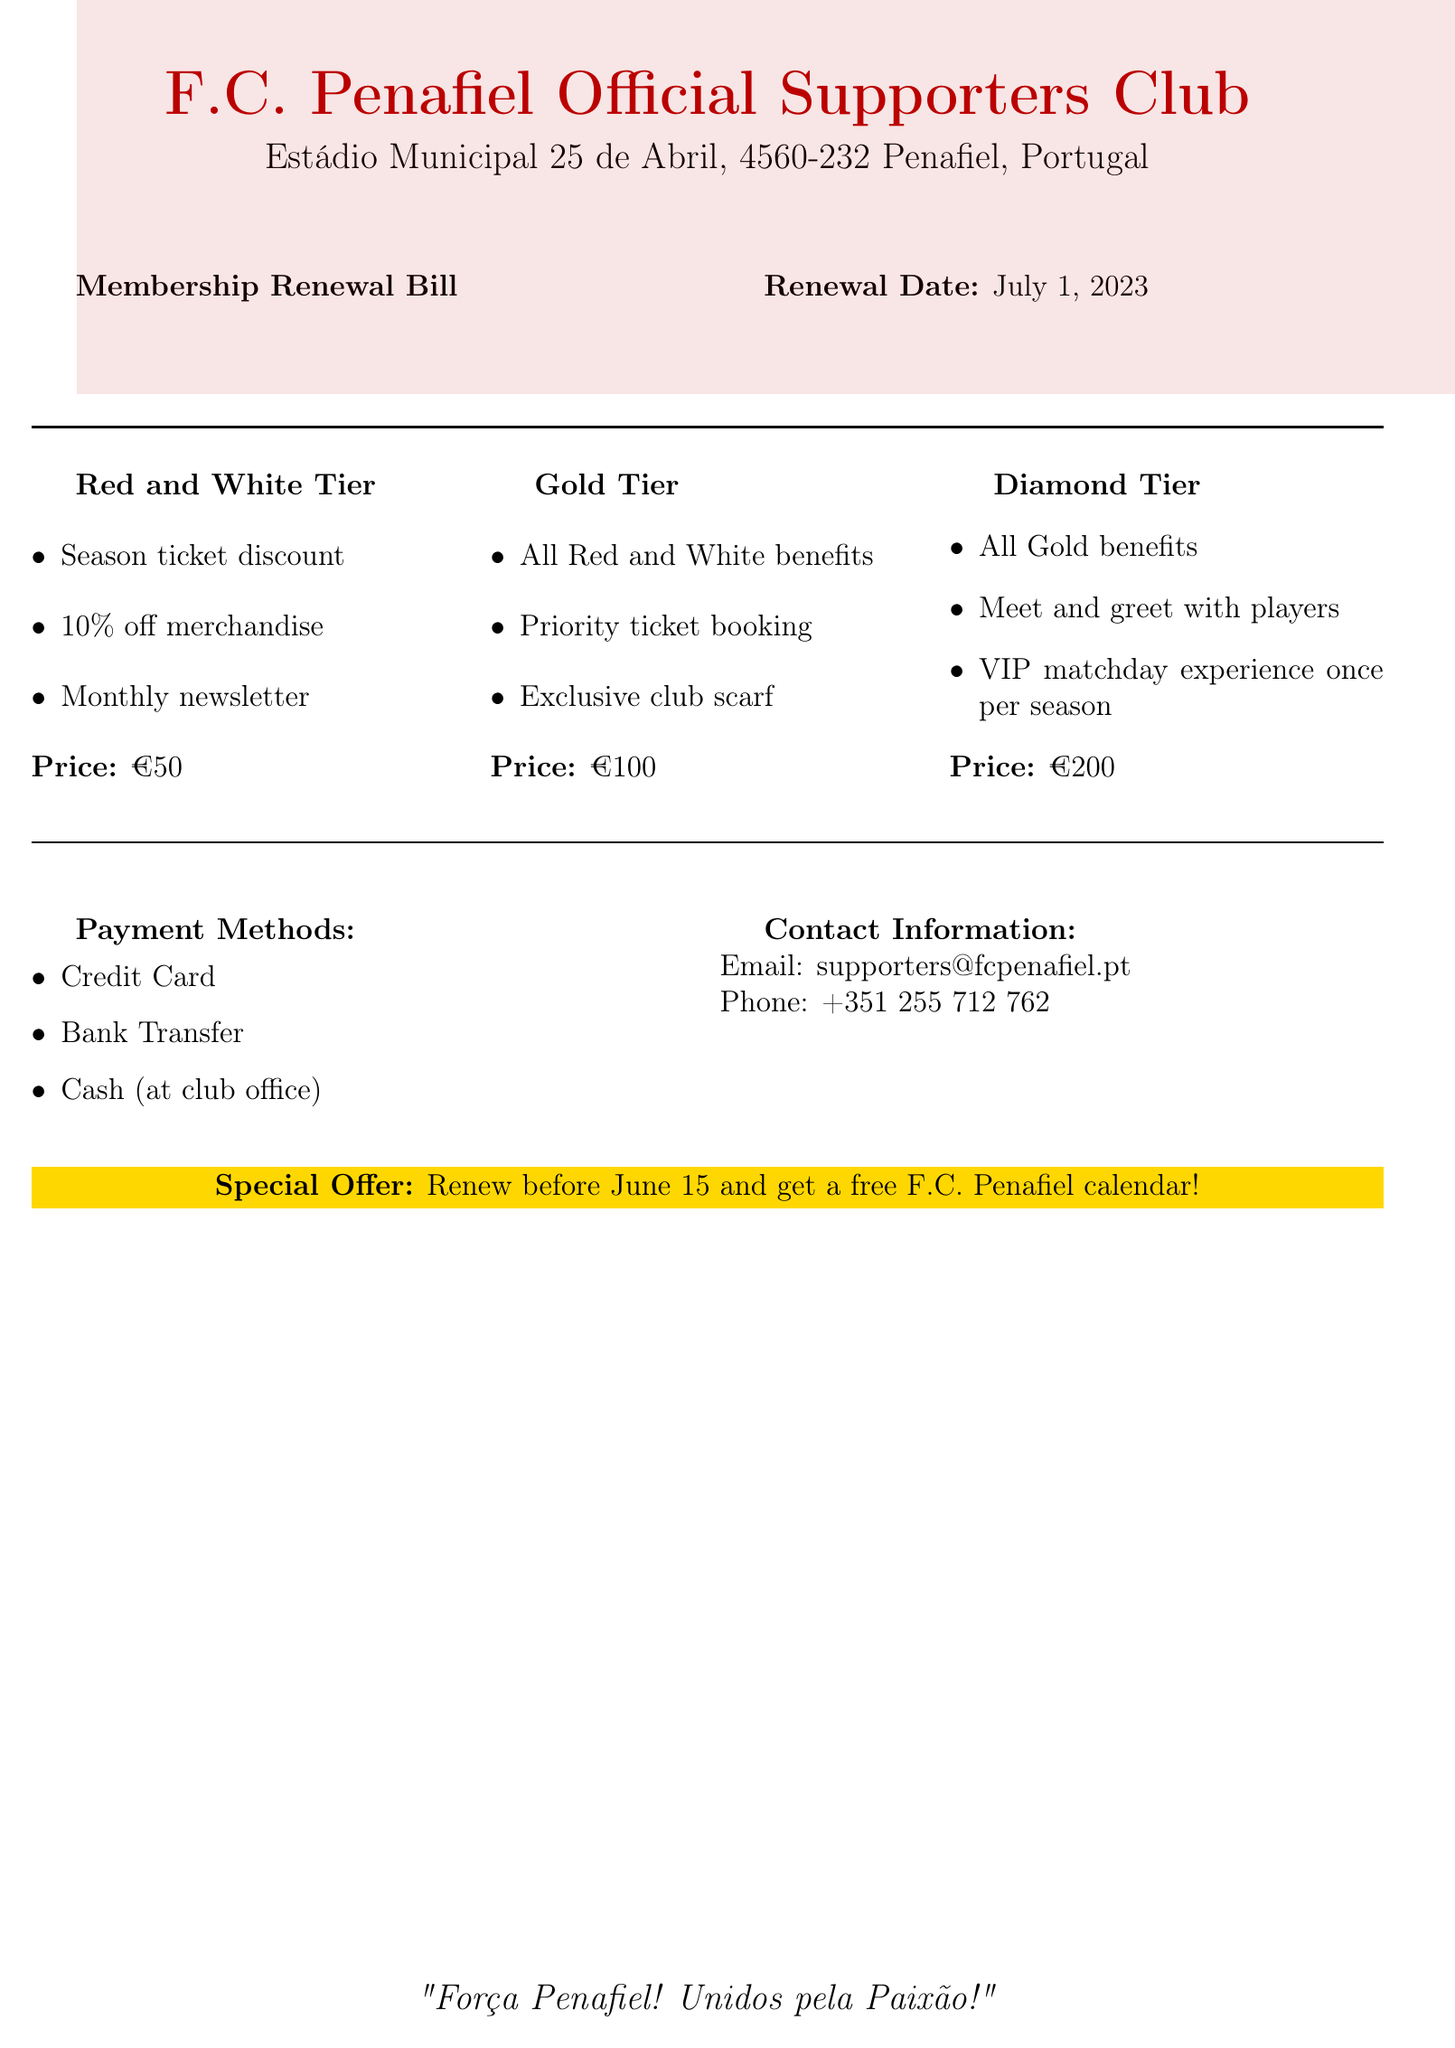What is the renewal date? The renewal date is clearly stated in the document.
Answer: July 1, 2023 What is the price of the Gold Tier? The document lists the price under each membership tier.
Answer: €100 Which benefits are exclusive to the Diamond Tier? The document outlines specific benefits for each membership tier, highlighting those unique to the Diamond Tier.
Answer: Meet and greet with players; VIP matchday experience once per season What special offer is available for early renewal? The document mentions a promotion for early renewals.
Answer: Free F.C. Penafiel calendar How many membership tiers are listed? The document details three distinct membership tiers.
Answer: Three What payment methods are accepted? Payment methods are specified in the document.
Answer: Credit Card, Bank Transfer, Cash Which benefits are included in the Red and White Tier? The document provides a list of benefits associated with the Red and White Tier specifically.
Answer: Season ticket discount; 10% off merchandise; Monthly newsletter What is the contact email for the supporters club? The document provides contact information for inquiries.
Answer: supporters@fcpenafiel.pt 